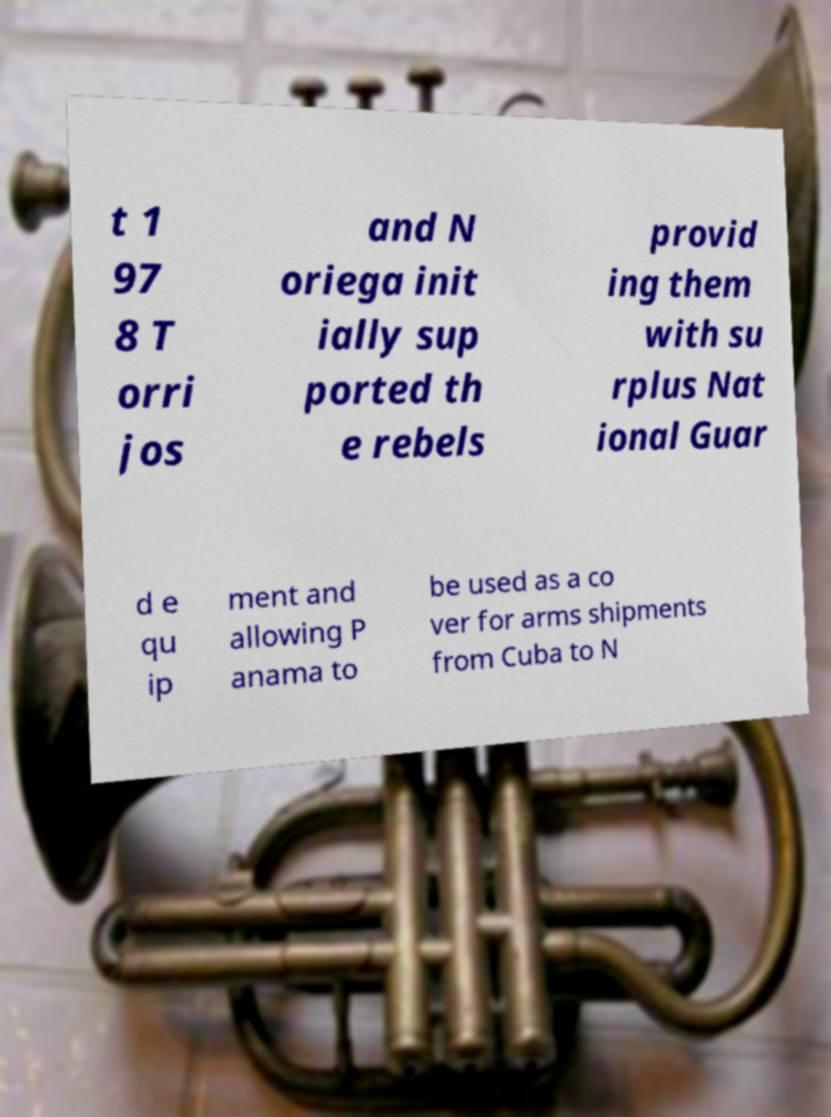Please read and relay the text visible in this image. What does it say? t 1 97 8 T orri jos and N oriega init ially sup ported th e rebels provid ing them with su rplus Nat ional Guar d e qu ip ment and allowing P anama to be used as a co ver for arms shipments from Cuba to N 